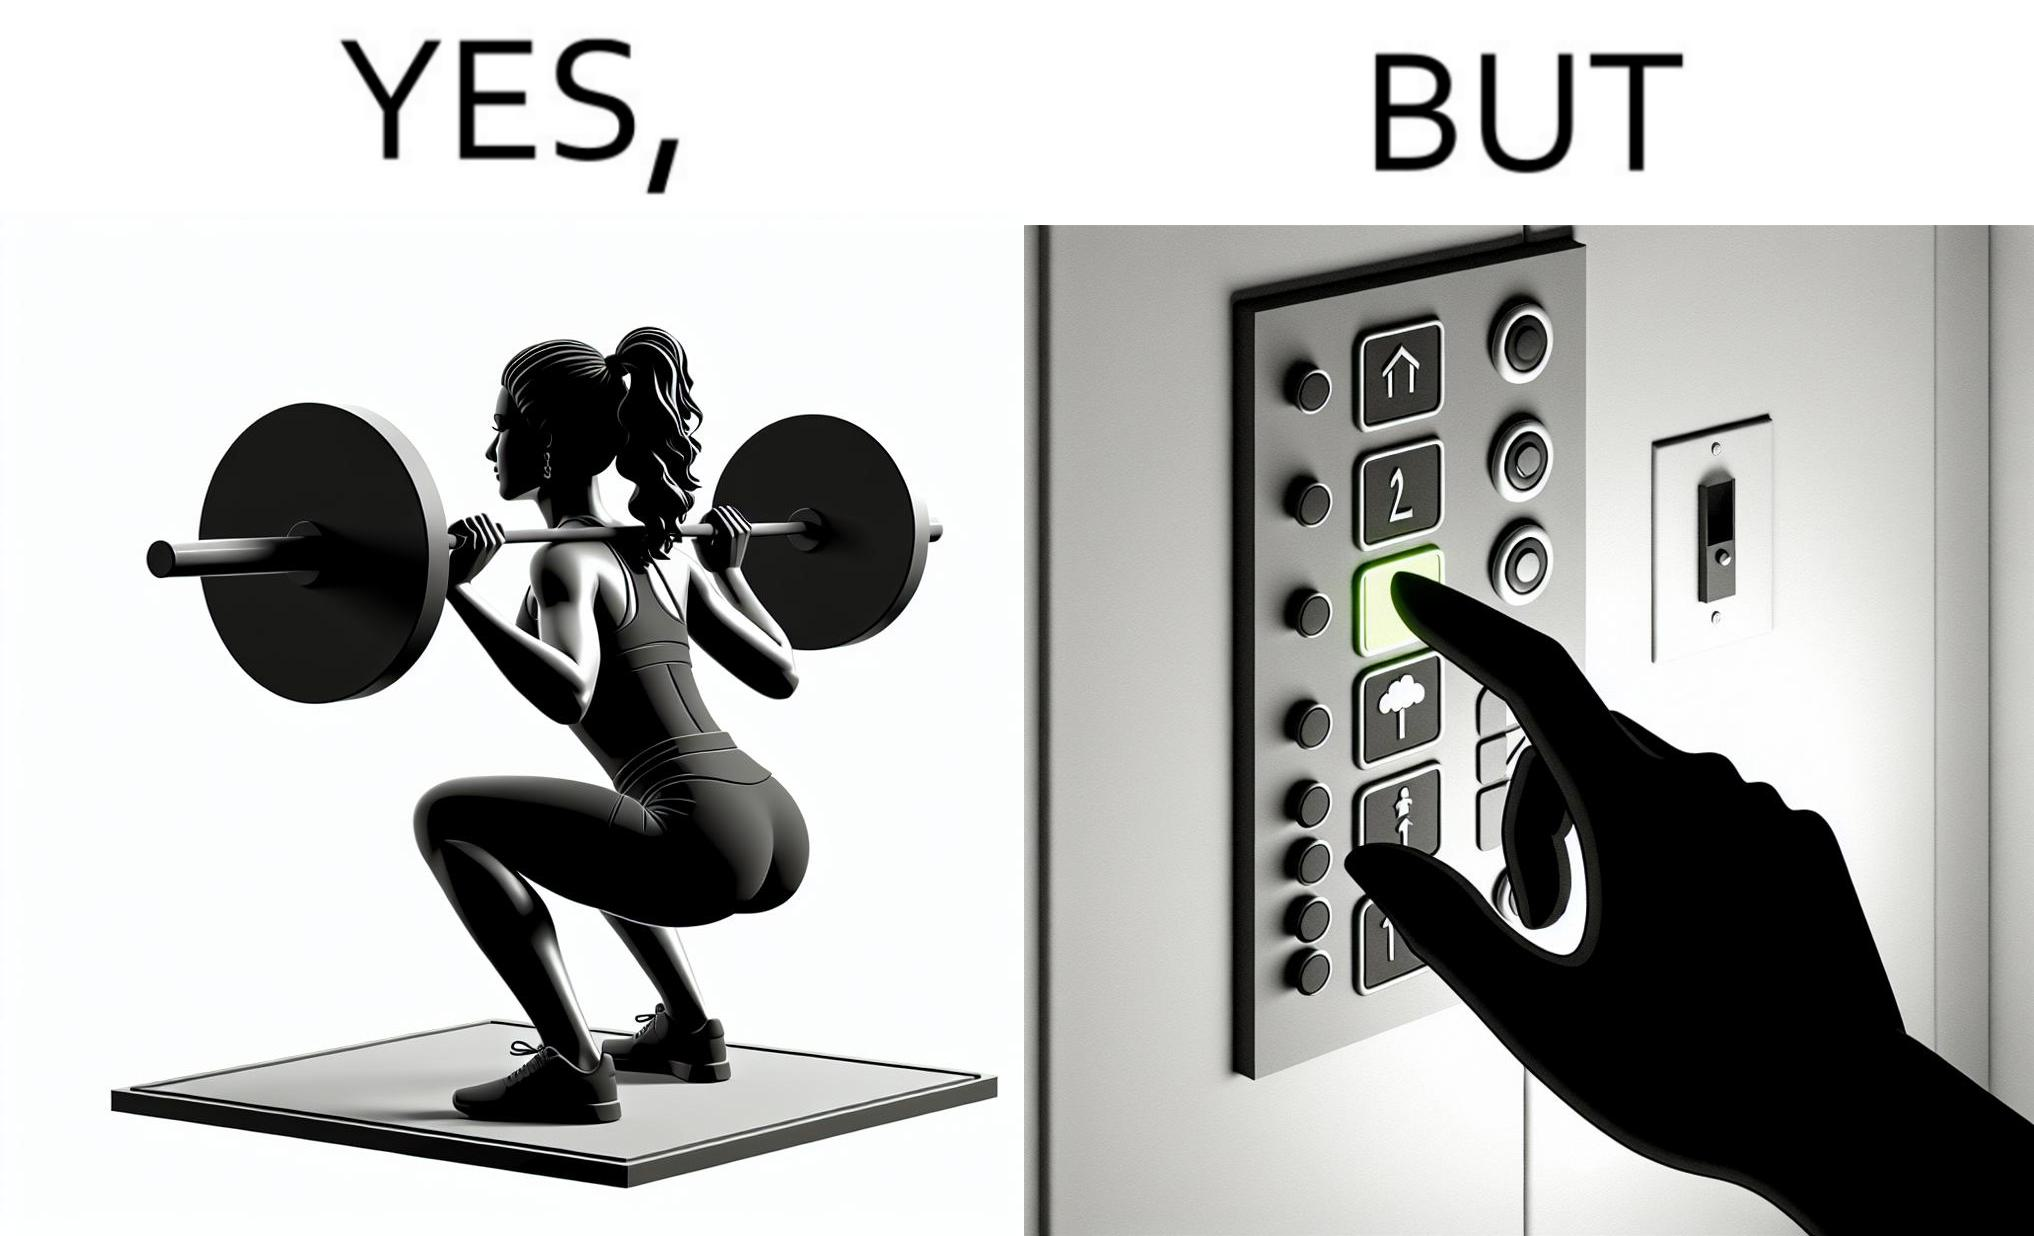Describe the satirical element in this image. The image is satirical because it shows that while people do various kinds of exercises and go to gym to stay fit, they avoid doing simplest of physical tasks like using stairs instead of elevators to get to even the first or the second floor of a building. 